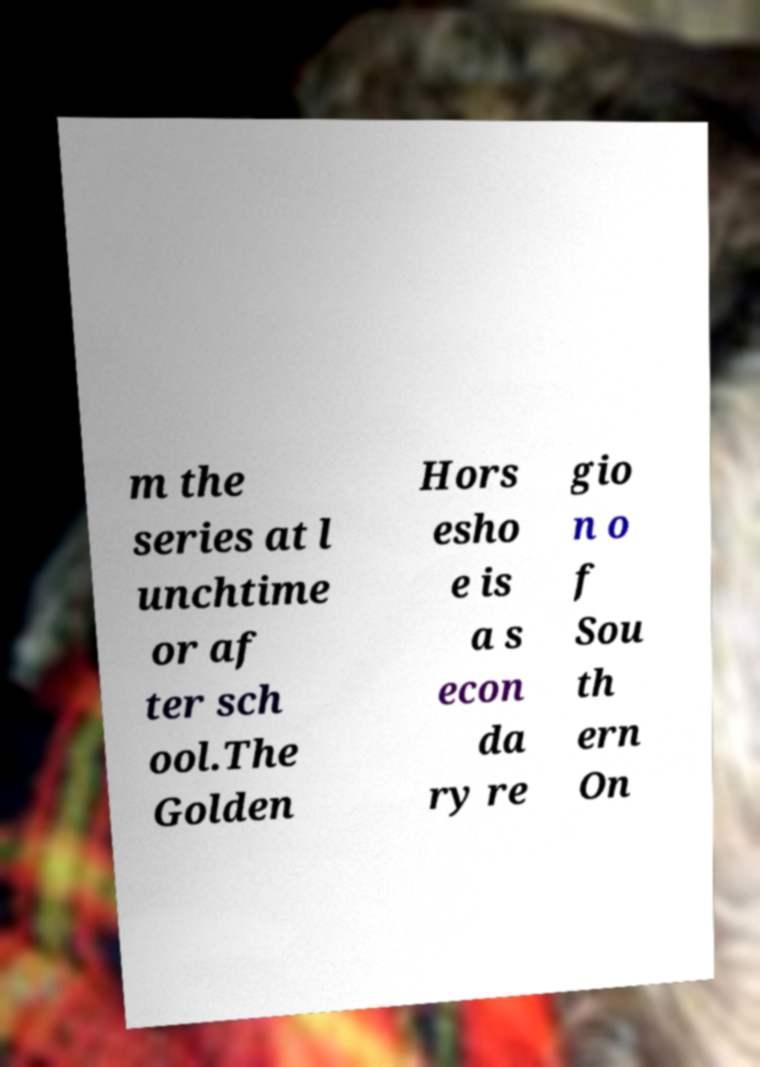Could you extract and type out the text from this image? m the series at l unchtime or af ter sch ool.The Golden Hors esho e is a s econ da ry re gio n o f Sou th ern On 